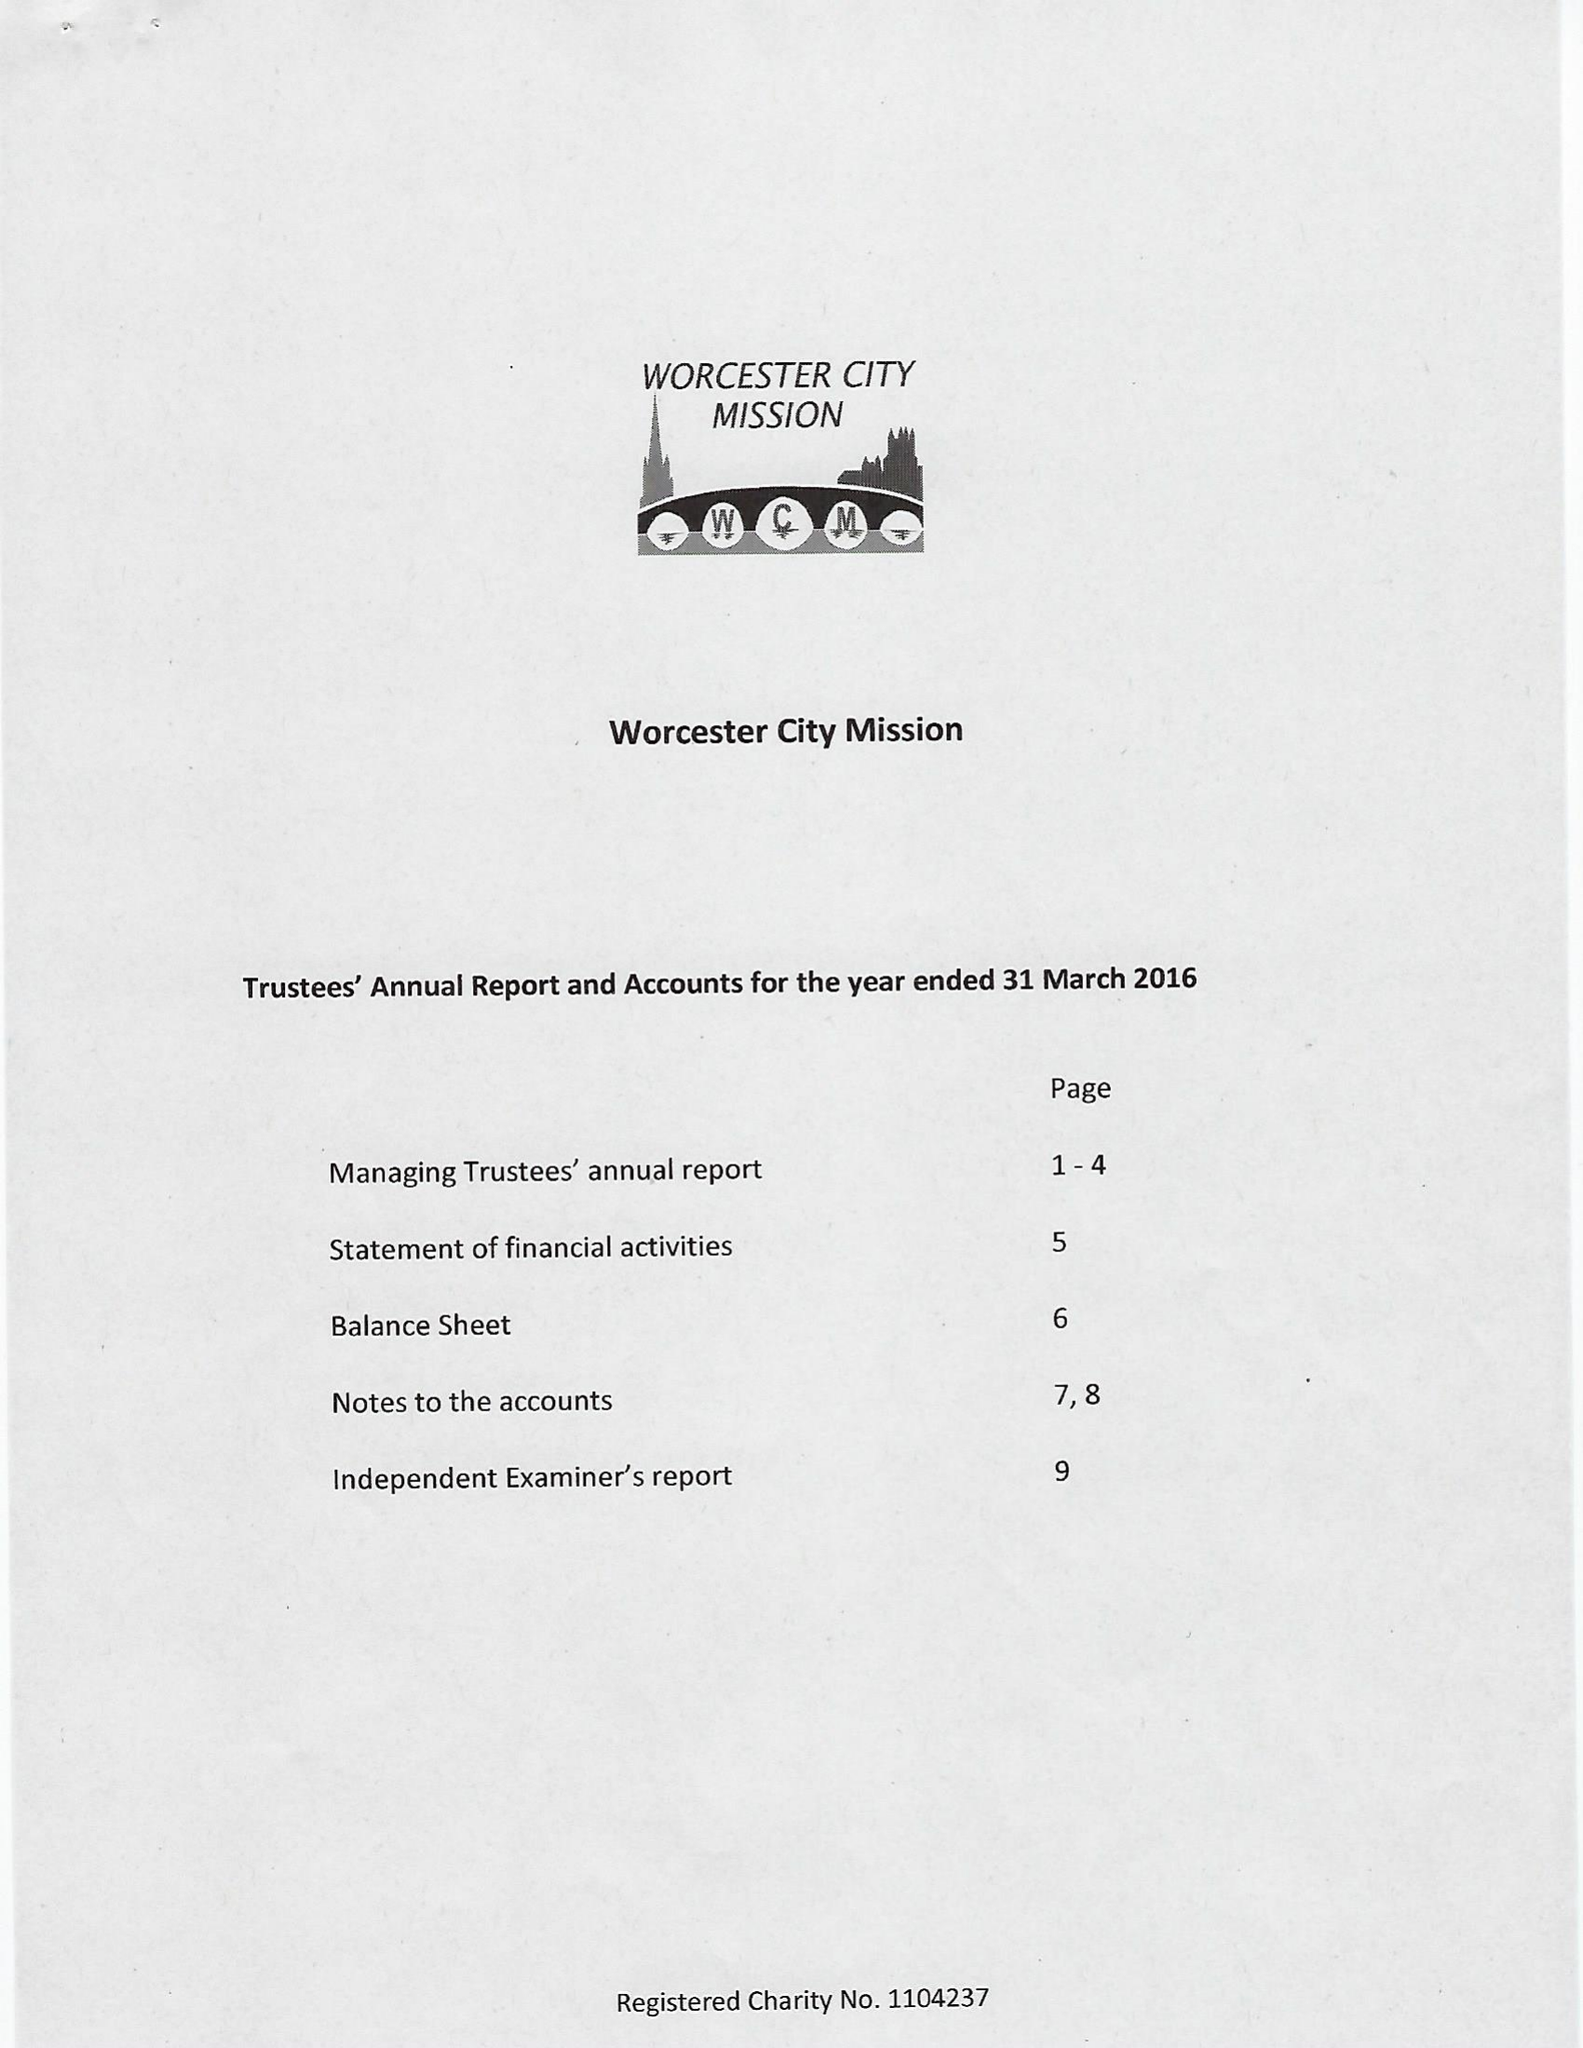What is the value for the address__postcode?
Answer the question using a single word or phrase. WR2 6NG 